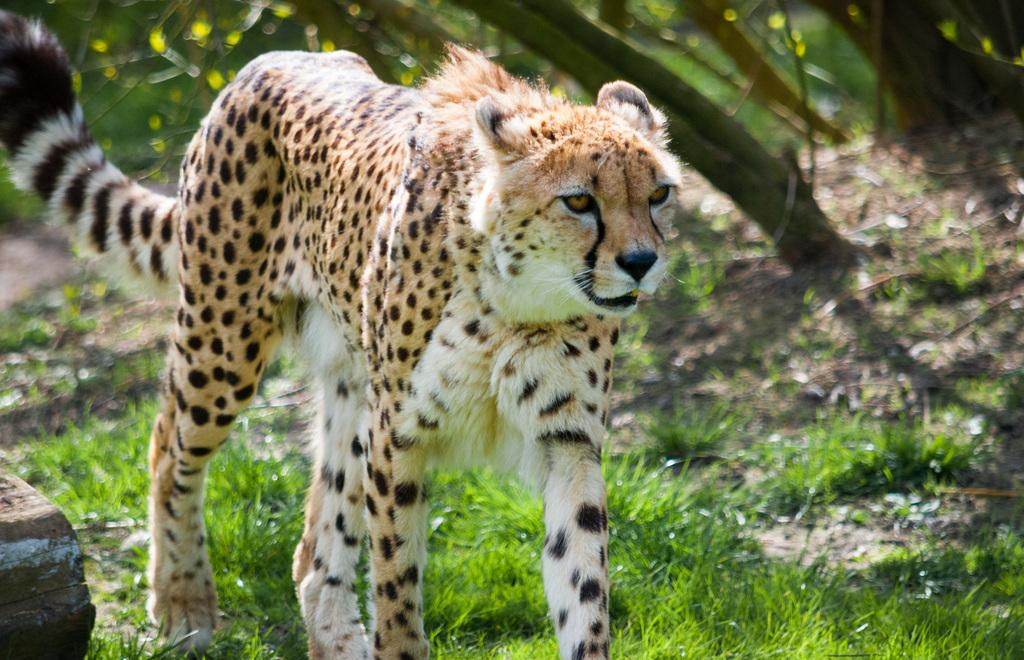What animal is in the image? There is a cheetah in the image. What is the cheetah doing in the image? The cheetah is walking on the grass. Can you describe the object in the left bottom corner of the image? Unfortunately, the facts provided do not give any information about the object in the left bottom corner. What can be seen in the background of the image? Trees are visible in the background of the image, although it is blurred. What type of vase is placed on the grass next to the cheetah in the image? There is no vase present in the image; it features a cheetah walking on the grass. Can you tell me how many icicles are hanging from the trees in the background of the image? There is no mention of icicles in the image; the trees in the background are blurred. 